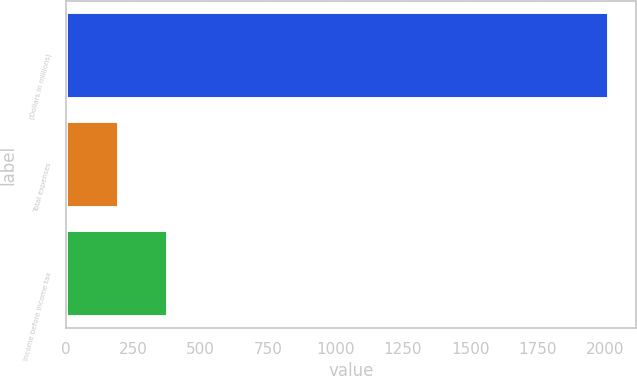Convert chart. <chart><loc_0><loc_0><loc_500><loc_500><bar_chart><fcel>(Dollars in millions)<fcel>Total expenses<fcel>Income before income tax<nl><fcel>2016<fcel>199<fcel>380.7<nl></chart> 